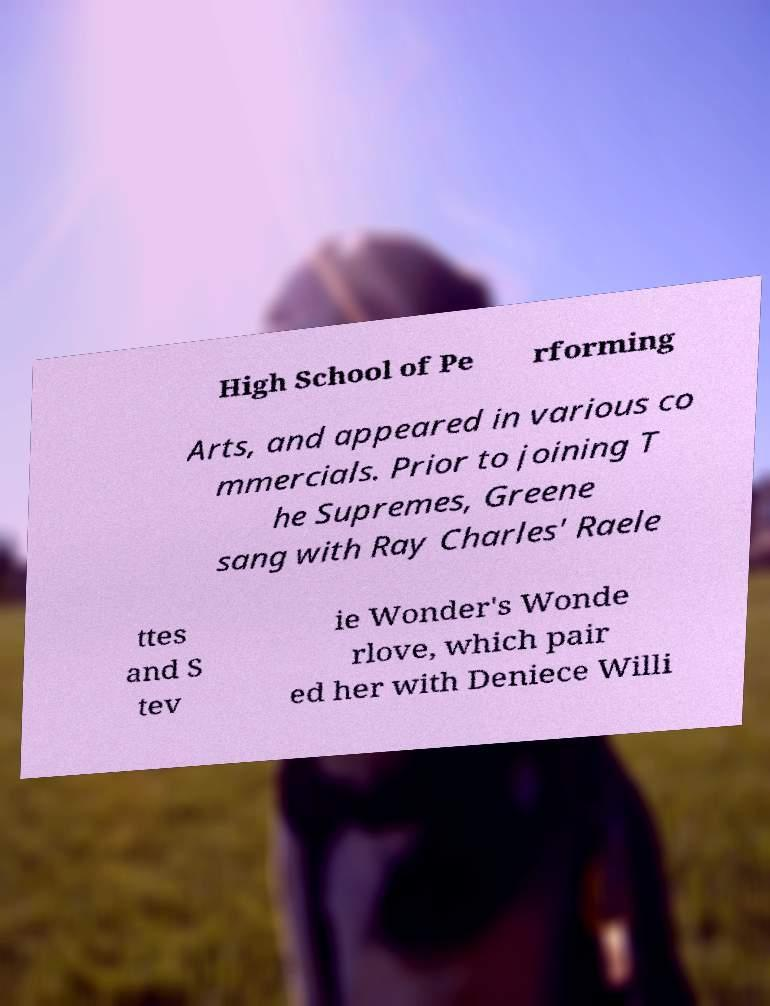Could you assist in decoding the text presented in this image and type it out clearly? High School of Pe rforming Arts, and appeared in various co mmercials. Prior to joining T he Supremes, Greene sang with Ray Charles' Raele ttes and S tev ie Wonder's Wonde rlove, which pair ed her with Deniece Willi 